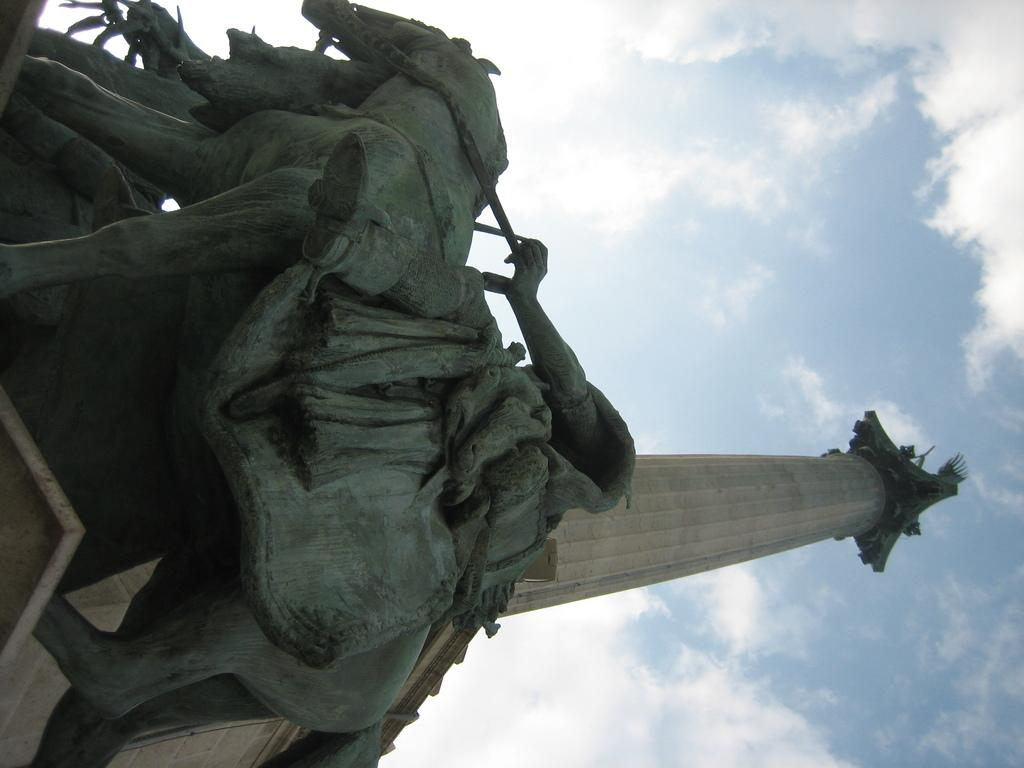What type of art can be seen in the image? There are sculptures in the image. What structure is visible in the background of the image? There is a tower in the background of the image. What can be seen in the sky in the image? There are clouds in the sky in the image. What type of veil is draped over the sculptures in the image? There is no veil present in the image; the sculptures are not covered. 